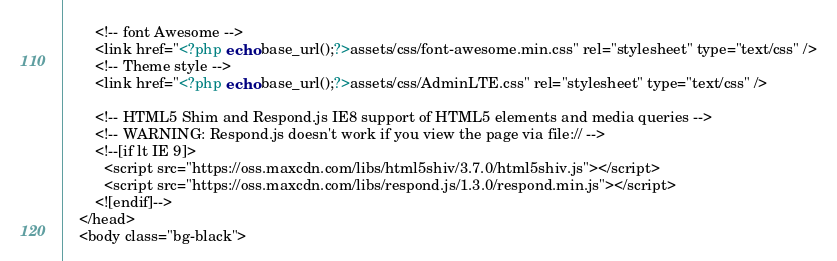<code> <loc_0><loc_0><loc_500><loc_500><_PHP_>        <!-- font Awesome -->
        <link href="<?php echo base_url();?>assets/css/font-awesome.min.css" rel="stylesheet" type="text/css" />
        <!-- Theme style -->
        <link href="<?php echo base_url();?>assets/css/AdminLTE.css" rel="stylesheet" type="text/css" />

        <!-- HTML5 Shim and Respond.js IE8 support of HTML5 elements and media queries -->
        <!-- WARNING: Respond.js doesn't work if you view the page via file:// -->
        <!--[if lt IE 9]>
          <script src="https://oss.maxcdn.com/libs/html5shiv/3.7.0/html5shiv.js"></script>
          <script src="https://oss.maxcdn.com/libs/respond.js/1.3.0/respond.min.js"></script>
        <![endif]-->
    </head>
    <body class="bg-black"></code> 